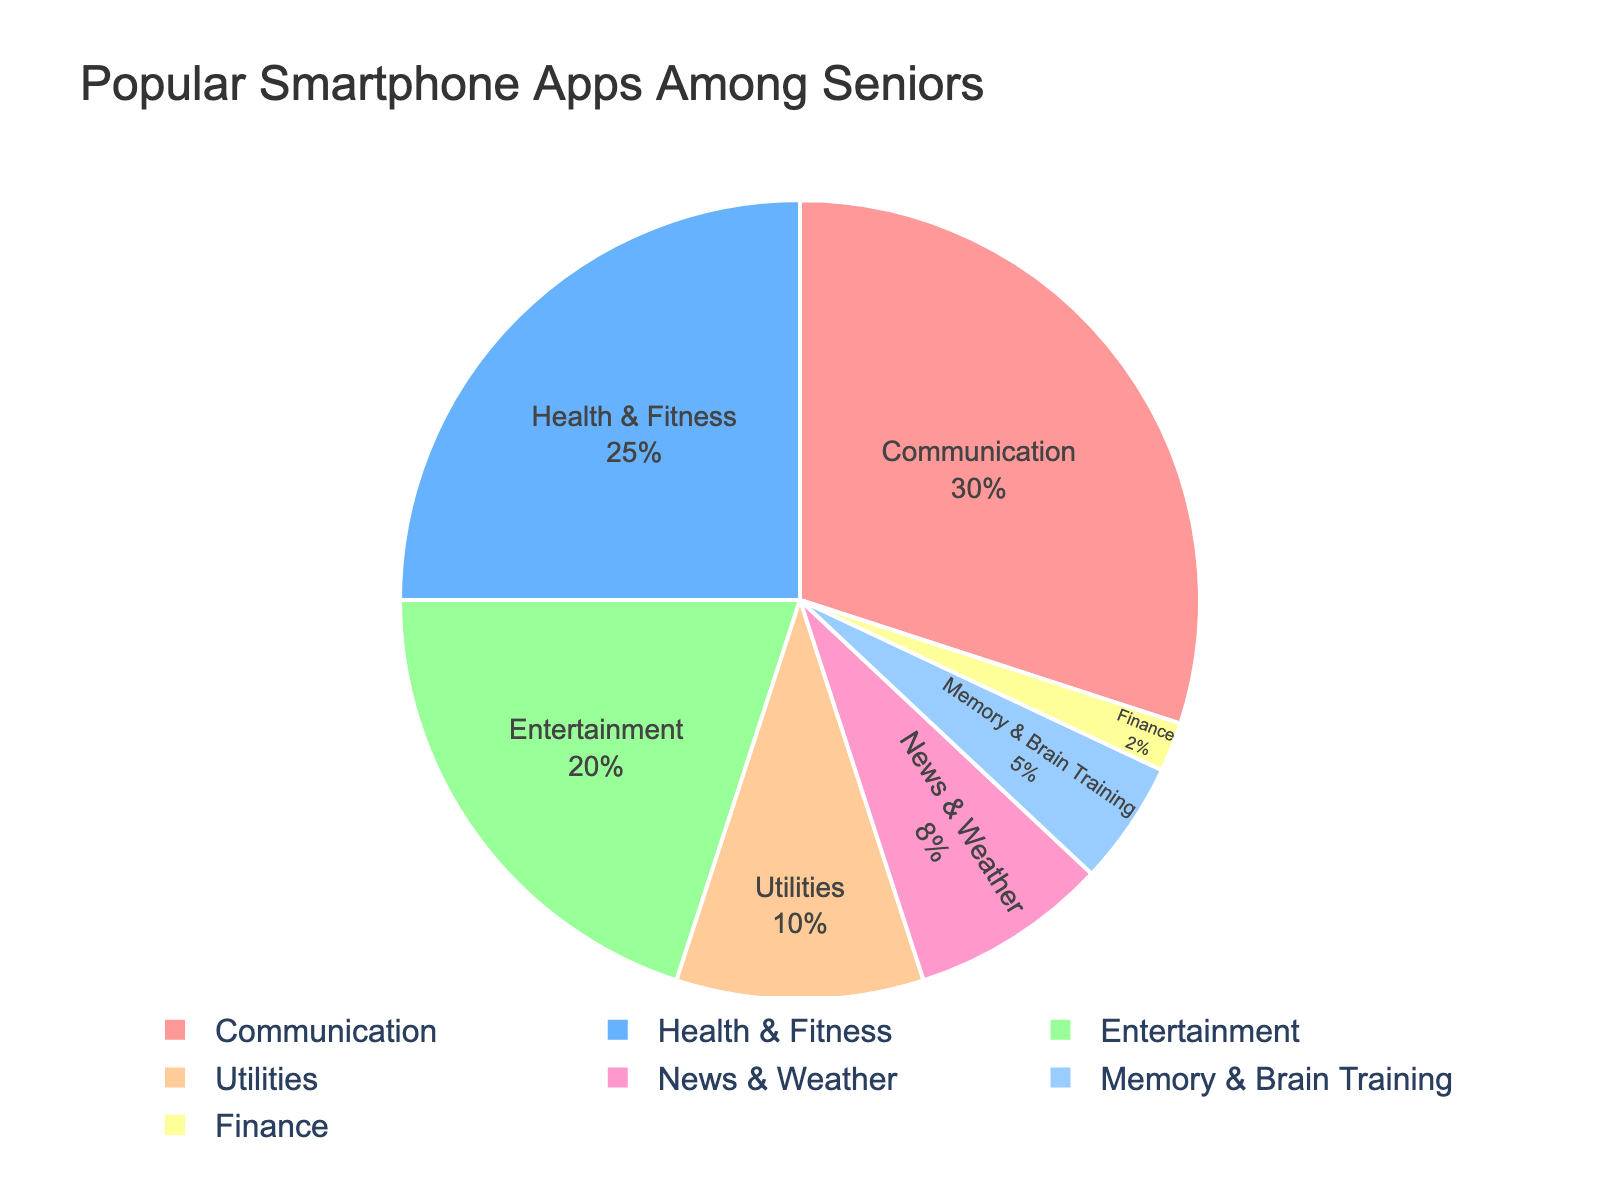What's the most popular category of apps among seniors? The largest segment in the pie chart represents the most popular category. The chart shows that the Communication category has the largest slice, indicating it is the most popular.
Answer: Communication Which categories have equal or less than 5% usage? To find categories with 5% or less, look for the smallest slices in the pie chart. The Memory & Brain Training category is 5%, and the Finance category is 2%.
Answer: Memory & Brain Training, Finance By how much does the percentage of Health & Fitness apps exceed News & Weather apps? Subtract the percentage of News & Weather from Health & Fitness. Health & Fitness is 25% and News & Weather is 8%, so the difference is 25 - 8 = 17%.
Answer: 17% Which category of apps is less popular than Entertainment but more popular than Utilities? Compare the slices between Entertainment (20%) and Utilities (10%). Health & Fitness falls within this range, at 25%.
Answer: Health & Fitness What's the combined percentage of Communication and Entertainment apps? Add the percentages of Communication and Entertainment from the pie chart. Communication is 30% and Entertainment is 20%, so the total is 30 + 20 = 50%.
Answer: 50% Identify the categories whose combined usage is less than Health & Fitness. Sum up the smaller categories until the total is less than Health & Fitness (25%). News & Weather (8%), Memory & Brain Training (5%), and Finance (2%) add up to 15%, which is less than 25%.
Answer: News & Weather, Memory & Brain Training, Finance Which slices are shown in shades of blue? Identify the visual attributes (color) of the slices directly from the chart. In this case, Utilities (10%) and Memory & Brain Training (5%) are shown in shades of blue.
Answer: Utilities, Memory & Brain Training 